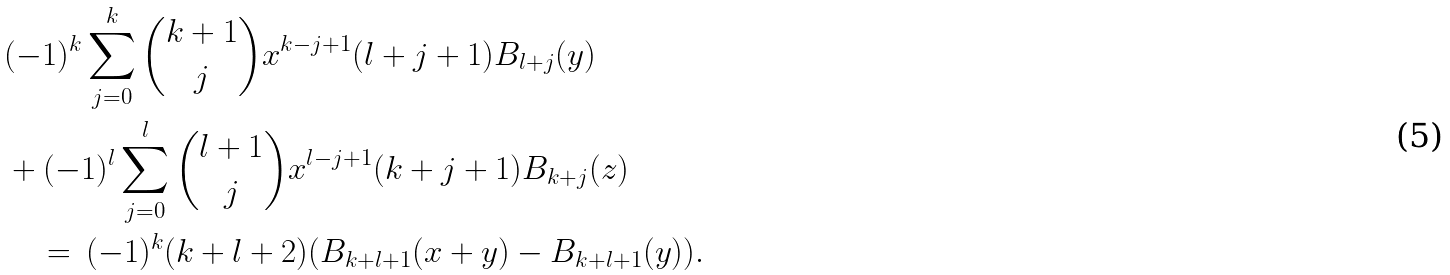<formula> <loc_0><loc_0><loc_500><loc_500>& ( - 1 ) ^ { k } \sum _ { j = 0 } ^ { k } { k + 1 \choose j } x ^ { k - j + 1 } ( l + j + 1 ) B _ { l + j } ( y ) \\ & + ( - 1 ) ^ { l } \sum _ { j = 0 } ^ { l } { l + 1 \choose j } x ^ { l - j + 1 } ( k + j + 1 ) B _ { k + j } ( z ) \\ & \quad = \, ( - 1 ) ^ { k } ( k + l + 2 ) ( B _ { k + l + 1 } ( x + y ) - B _ { k + l + 1 } ( y ) ) .</formula> 